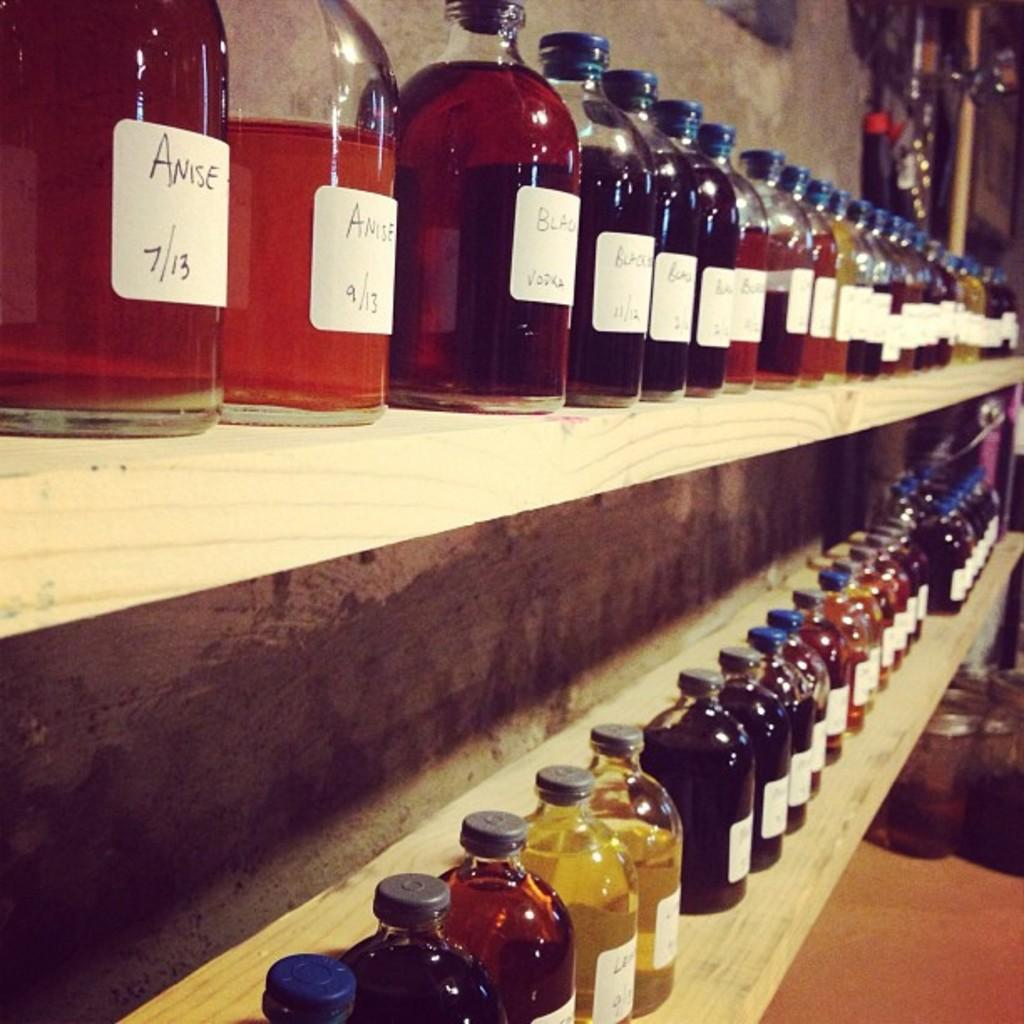<image>
Render a clear and concise summary of the photo. a few shelves full of tinctures such as Anise and others. 